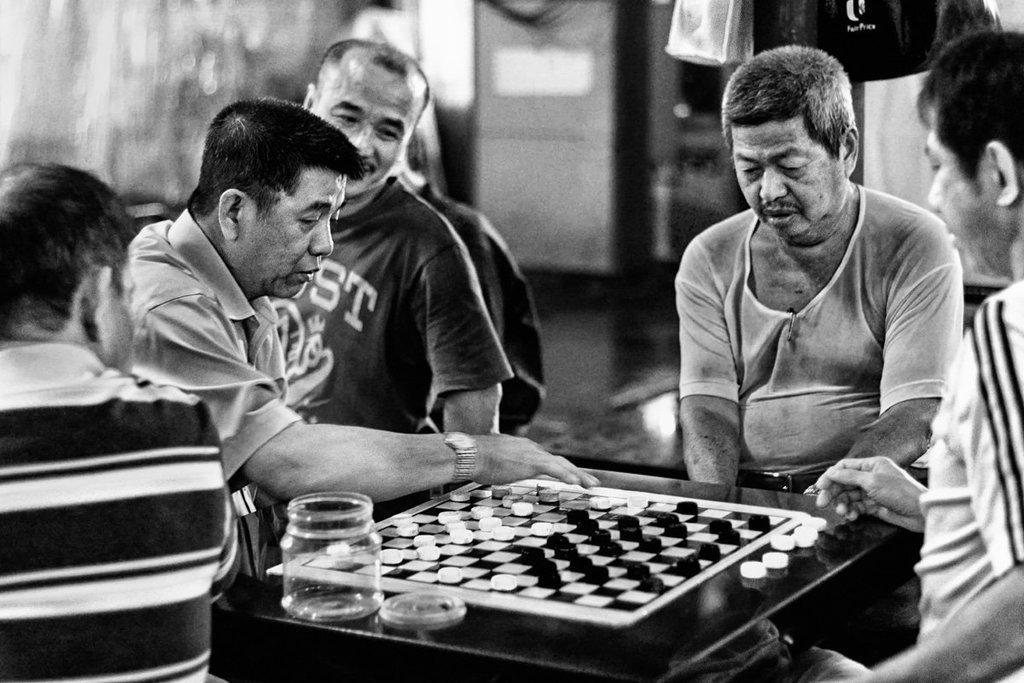In one or two sentences, can you explain what this image depicts? In this image there are group of people who are playing with the coins by keeping them on board. There are four people who are playing with the coins and the person in the background is looking at the board. There is a jar on the board. 